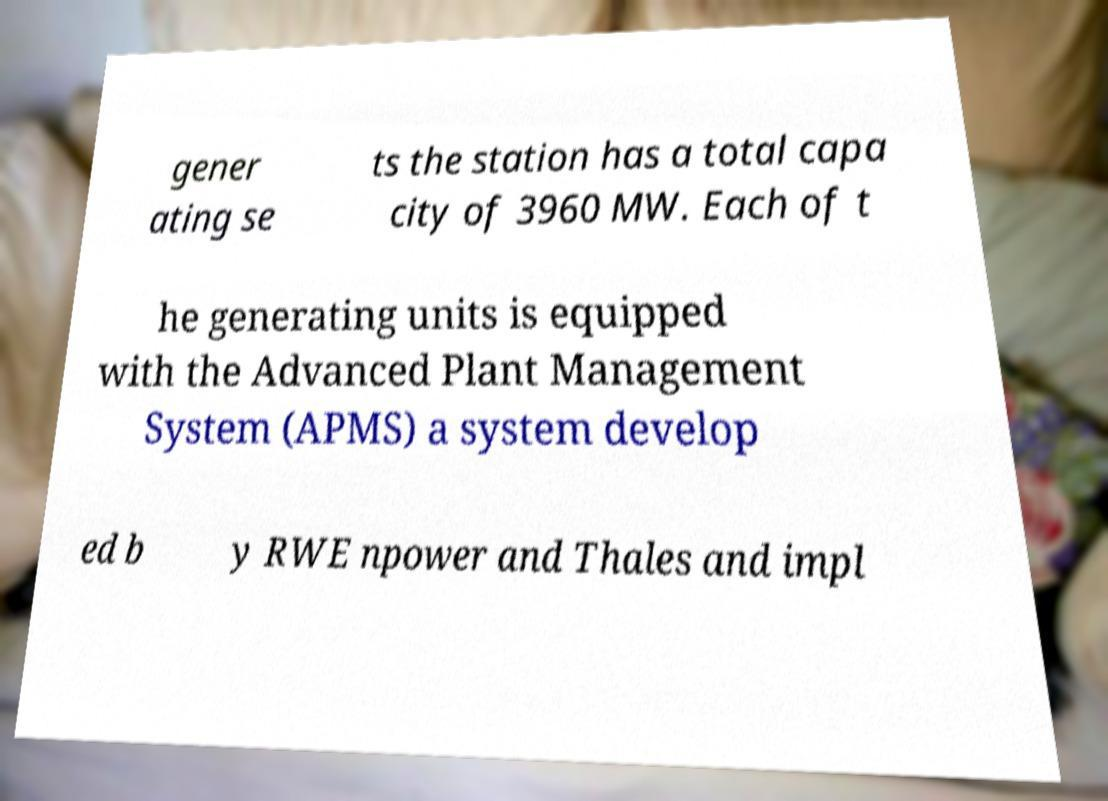Could you extract and type out the text from this image? gener ating se ts the station has a total capa city of 3960 MW. Each of t he generating units is equipped with the Advanced Plant Management System (APMS) a system develop ed b y RWE npower and Thales and impl 